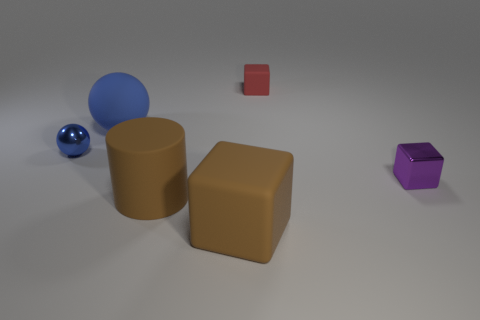Subtract all rubber cubes. How many cubes are left? 1 Subtract 1 blocks. How many blocks are left? 2 Add 1 brown things. How many objects exist? 7 Subtract all balls. How many objects are left? 4 Subtract 0 gray cylinders. How many objects are left? 6 Subtract all small purple blocks. Subtract all brown objects. How many objects are left? 3 Add 5 brown matte cylinders. How many brown matte cylinders are left? 6 Add 5 gray matte cylinders. How many gray matte cylinders exist? 5 